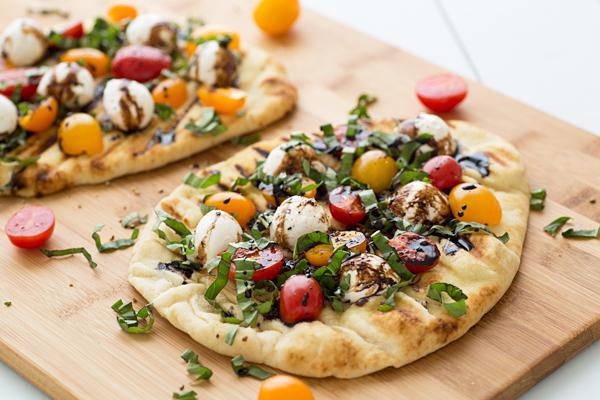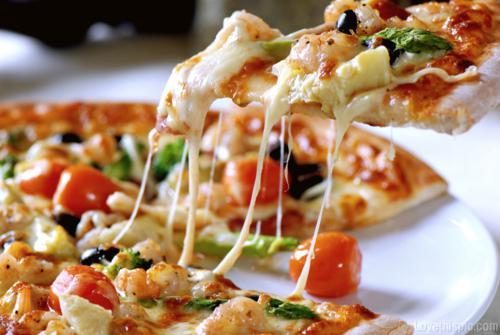The first image is the image on the left, the second image is the image on the right. Examine the images to the left and right. Is the description "There are whole tomatoes." accurate? Answer yes or no. Yes. The first image is the image on the left, the second image is the image on the right. Given the left and right images, does the statement "There are multiple pizzas in one of the images and only one pizza in the other image." hold true? Answer yes or no. Yes. 